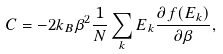Convert formula to latex. <formula><loc_0><loc_0><loc_500><loc_500>C = - 2 k _ { B } \beta ^ { 2 } \frac { 1 } { N } \sum _ { k } E _ { k } \frac { \partial f ( E _ { k } ) } { \partial \beta } ,</formula> 